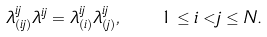<formula> <loc_0><loc_0><loc_500><loc_500>\lambda ^ { i j } _ { ( i j ) } \lambda ^ { i j } = \lambda ^ { i j } _ { ( i ) } \lambda ^ { i j } _ { ( j ) } , \quad 1 \leq i < j \leq N .</formula> 